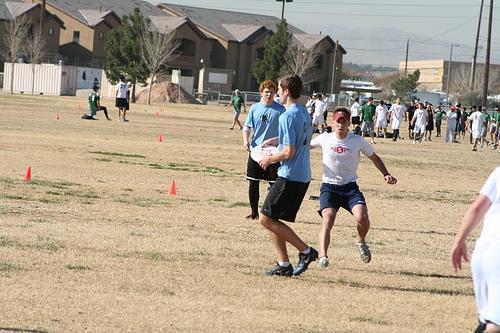How many boys are holding Frisbees?
Give a very brief answer. 1. How many people are in the picture?
Give a very brief answer. 4. How many laptops can be seen?
Give a very brief answer. 0. 